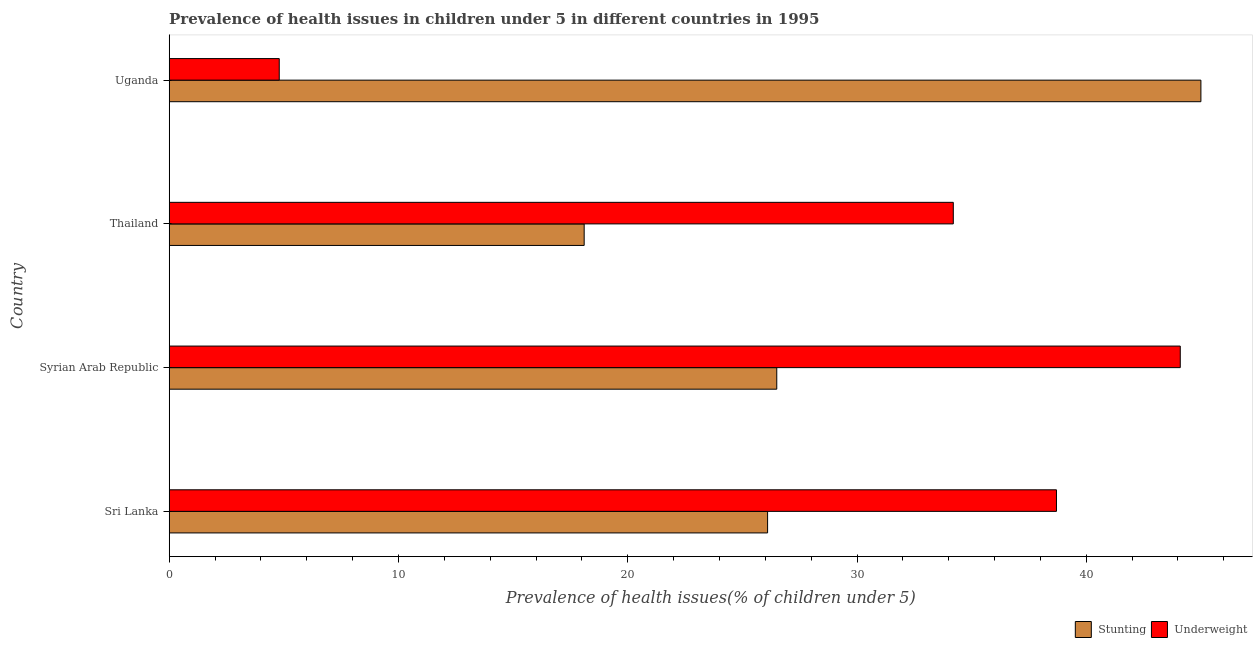How many groups of bars are there?
Keep it short and to the point. 4. Are the number of bars per tick equal to the number of legend labels?
Make the answer very short. Yes. How many bars are there on the 4th tick from the top?
Give a very brief answer. 2. How many bars are there on the 3rd tick from the bottom?
Provide a succinct answer. 2. What is the label of the 4th group of bars from the top?
Offer a terse response. Sri Lanka. In how many cases, is the number of bars for a given country not equal to the number of legend labels?
Provide a short and direct response. 0. What is the percentage of stunted children in Thailand?
Provide a short and direct response. 18.1. Across all countries, what is the minimum percentage of stunted children?
Make the answer very short. 18.1. In which country was the percentage of underweight children maximum?
Provide a succinct answer. Syrian Arab Republic. In which country was the percentage of underweight children minimum?
Offer a terse response. Uganda. What is the total percentage of stunted children in the graph?
Offer a terse response. 115.7. What is the difference between the percentage of underweight children in Sri Lanka and that in Uganda?
Your answer should be very brief. 33.9. What is the difference between the percentage of stunted children in Syrian Arab Republic and the percentage of underweight children in Uganda?
Offer a very short reply. 21.7. What is the average percentage of stunted children per country?
Your answer should be very brief. 28.93. What is the difference between the percentage of stunted children and percentage of underweight children in Syrian Arab Republic?
Provide a succinct answer. -17.6. In how many countries, is the percentage of underweight children greater than 36 %?
Provide a succinct answer. 2. What is the ratio of the percentage of underweight children in Syrian Arab Republic to that in Uganda?
Your answer should be very brief. 9.19. What is the difference between the highest and the lowest percentage of stunted children?
Offer a very short reply. 26.9. Is the sum of the percentage of stunted children in Syrian Arab Republic and Uganda greater than the maximum percentage of underweight children across all countries?
Give a very brief answer. Yes. What does the 2nd bar from the top in Syrian Arab Republic represents?
Ensure brevity in your answer.  Stunting. What does the 1st bar from the bottom in Thailand represents?
Your response must be concise. Stunting. How many bars are there?
Ensure brevity in your answer.  8. Are all the bars in the graph horizontal?
Your answer should be compact. Yes. How many countries are there in the graph?
Give a very brief answer. 4. What is the difference between two consecutive major ticks on the X-axis?
Make the answer very short. 10. Does the graph contain grids?
Your response must be concise. No. What is the title of the graph?
Provide a short and direct response. Prevalence of health issues in children under 5 in different countries in 1995. Does "Drinking water services" appear as one of the legend labels in the graph?
Offer a terse response. No. What is the label or title of the X-axis?
Offer a terse response. Prevalence of health issues(% of children under 5). What is the Prevalence of health issues(% of children under 5) in Stunting in Sri Lanka?
Keep it short and to the point. 26.1. What is the Prevalence of health issues(% of children under 5) of Underweight in Sri Lanka?
Your answer should be compact. 38.7. What is the Prevalence of health issues(% of children under 5) in Stunting in Syrian Arab Republic?
Ensure brevity in your answer.  26.5. What is the Prevalence of health issues(% of children under 5) in Underweight in Syrian Arab Republic?
Ensure brevity in your answer.  44.1. What is the Prevalence of health issues(% of children under 5) of Stunting in Thailand?
Give a very brief answer. 18.1. What is the Prevalence of health issues(% of children under 5) in Underweight in Thailand?
Make the answer very short. 34.2. What is the Prevalence of health issues(% of children under 5) of Stunting in Uganda?
Ensure brevity in your answer.  45. What is the Prevalence of health issues(% of children under 5) of Underweight in Uganda?
Offer a terse response. 4.8. Across all countries, what is the maximum Prevalence of health issues(% of children under 5) in Stunting?
Provide a succinct answer. 45. Across all countries, what is the maximum Prevalence of health issues(% of children under 5) of Underweight?
Keep it short and to the point. 44.1. Across all countries, what is the minimum Prevalence of health issues(% of children under 5) of Stunting?
Provide a short and direct response. 18.1. Across all countries, what is the minimum Prevalence of health issues(% of children under 5) in Underweight?
Keep it short and to the point. 4.8. What is the total Prevalence of health issues(% of children under 5) of Stunting in the graph?
Provide a short and direct response. 115.7. What is the total Prevalence of health issues(% of children under 5) in Underweight in the graph?
Ensure brevity in your answer.  121.8. What is the difference between the Prevalence of health issues(% of children under 5) of Stunting in Sri Lanka and that in Syrian Arab Republic?
Ensure brevity in your answer.  -0.4. What is the difference between the Prevalence of health issues(% of children under 5) of Underweight in Sri Lanka and that in Syrian Arab Republic?
Ensure brevity in your answer.  -5.4. What is the difference between the Prevalence of health issues(% of children under 5) of Stunting in Sri Lanka and that in Uganda?
Your answer should be compact. -18.9. What is the difference between the Prevalence of health issues(% of children under 5) in Underweight in Sri Lanka and that in Uganda?
Offer a terse response. 33.9. What is the difference between the Prevalence of health issues(% of children under 5) of Stunting in Syrian Arab Republic and that in Thailand?
Ensure brevity in your answer.  8.4. What is the difference between the Prevalence of health issues(% of children under 5) in Underweight in Syrian Arab Republic and that in Thailand?
Your response must be concise. 9.9. What is the difference between the Prevalence of health issues(% of children under 5) in Stunting in Syrian Arab Republic and that in Uganda?
Offer a terse response. -18.5. What is the difference between the Prevalence of health issues(% of children under 5) of Underweight in Syrian Arab Republic and that in Uganda?
Give a very brief answer. 39.3. What is the difference between the Prevalence of health issues(% of children under 5) in Stunting in Thailand and that in Uganda?
Keep it short and to the point. -26.9. What is the difference between the Prevalence of health issues(% of children under 5) of Underweight in Thailand and that in Uganda?
Provide a succinct answer. 29.4. What is the difference between the Prevalence of health issues(% of children under 5) in Stunting in Sri Lanka and the Prevalence of health issues(% of children under 5) in Underweight in Syrian Arab Republic?
Your answer should be very brief. -18. What is the difference between the Prevalence of health issues(% of children under 5) of Stunting in Sri Lanka and the Prevalence of health issues(% of children under 5) of Underweight in Thailand?
Provide a succinct answer. -8.1. What is the difference between the Prevalence of health issues(% of children under 5) in Stunting in Sri Lanka and the Prevalence of health issues(% of children under 5) in Underweight in Uganda?
Give a very brief answer. 21.3. What is the difference between the Prevalence of health issues(% of children under 5) in Stunting in Syrian Arab Republic and the Prevalence of health issues(% of children under 5) in Underweight in Uganda?
Give a very brief answer. 21.7. What is the average Prevalence of health issues(% of children under 5) of Stunting per country?
Ensure brevity in your answer.  28.93. What is the average Prevalence of health issues(% of children under 5) of Underweight per country?
Your answer should be very brief. 30.45. What is the difference between the Prevalence of health issues(% of children under 5) of Stunting and Prevalence of health issues(% of children under 5) of Underweight in Syrian Arab Republic?
Give a very brief answer. -17.6. What is the difference between the Prevalence of health issues(% of children under 5) in Stunting and Prevalence of health issues(% of children under 5) in Underweight in Thailand?
Provide a succinct answer. -16.1. What is the difference between the Prevalence of health issues(% of children under 5) of Stunting and Prevalence of health issues(% of children under 5) of Underweight in Uganda?
Offer a terse response. 40.2. What is the ratio of the Prevalence of health issues(% of children under 5) of Stunting in Sri Lanka to that in Syrian Arab Republic?
Provide a succinct answer. 0.98. What is the ratio of the Prevalence of health issues(% of children under 5) of Underweight in Sri Lanka to that in Syrian Arab Republic?
Give a very brief answer. 0.88. What is the ratio of the Prevalence of health issues(% of children under 5) of Stunting in Sri Lanka to that in Thailand?
Your answer should be very brief. 1.44. What is the ratio of the Prevalence of health issues(% of children under 5) in Underweight in Sri Lanka to that in Thailand?
Your answer should be compact. 1.13. What is the ratio of the Prevalence of health issues(% of children under 5) in Stunting in Sri Lanka to that in Uganda?
Provide a short and direct response. 0.58. What is the ratio of the Prevalence of health issues(% of children under 5) of Underweight in Sri Lanka to that in Uganda?
Provide a succinct answer. 8.06. What is the ratio of the Prevalence of health issues(% of children under 5) of Stunting in Syrian Arab Republic to that in Thailand?
Make the answer very short. 1.46. What is the ratio of the Prevalence of health issues(% of children under 5) of Underweight in Syrian Arab Republic to that in Thailand?
Provide a succinct answer. 1.29. What is the ratio of the Prevalence of health issues(% of children under 5) of Stunting in Syrian Arab Republic to that in Uganda?
Ensure brevity in your answer.  0.59. What is the ratio of the Prevalence of health issues(% of children under 5) of Underweight in Syrian Arab Republic to that in Uganda?
Make the answer very short. 9.19. What is the ratio of the Prevalence of health issues(% of children under 5) in Stunting in Thailand to that in Uganda?
Offer a very short reply. 0.4. What is the ratio of the Prevalence of health issues(% of children under 5) of Underweight in Thailand to that in Uganda?
Your answer should be very brief. 7.12. What is the difference between the highest and the second highest Prevalence of health issues(% of children under 5) of Underweight?
Offer a terse response. 5.4. What is the difference between the highest and the lowest Prevalence of health issues(% of children under 5) of Stunting?
Your answer should be very brief. 26.9. What is the difference between the highest and the lowest Prevalence of health issues(% of children under 5) in Underweight?
Offer a terse response. 39.3. 